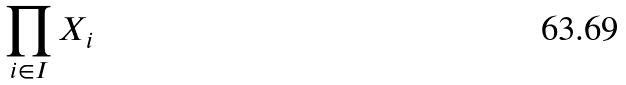Convert formula to latex. <formula><loc_0><loc_0><loc_500><loc_500>\prod _ { i \in I } X _ { i }</formula> 